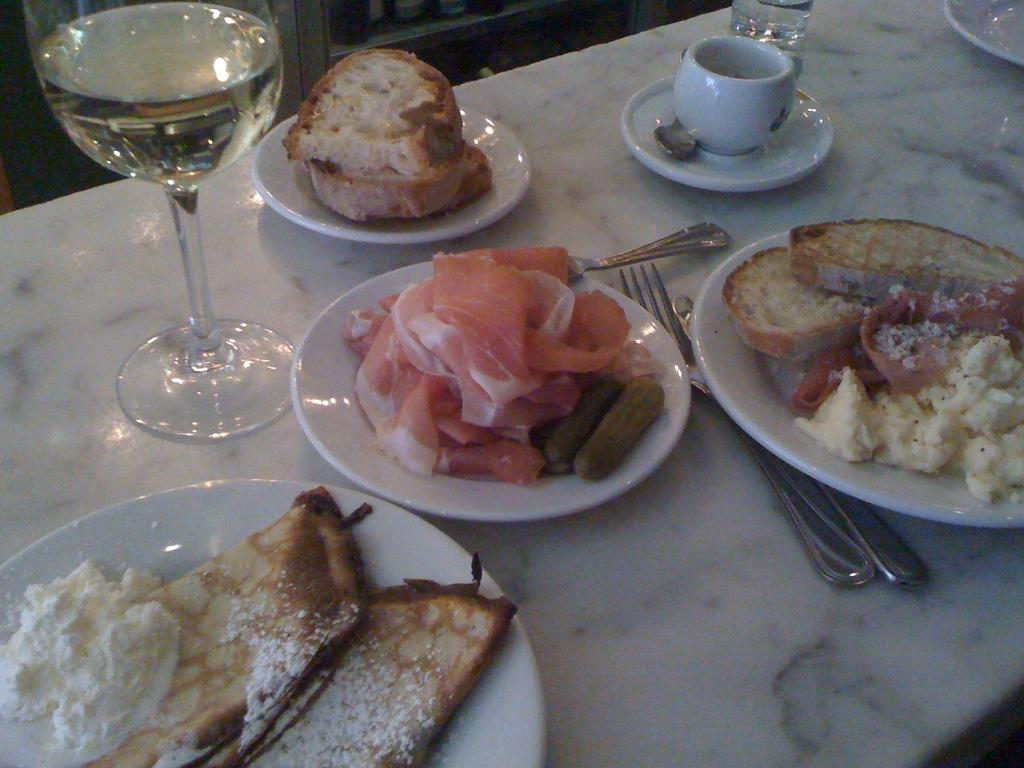What piece of furniture is present in the image? There is a table in the image. What is placed on the table? There are four plates with food items, glasses with liquid, cups, and spoons on the table. Can you describe the utensils present on the table? There are spoons and a fork on the table. What type of badge can be seen on the table in the image? There is no badge present on the table in the image. What type of grain is visible in the image? There is no grain visible in the image. 